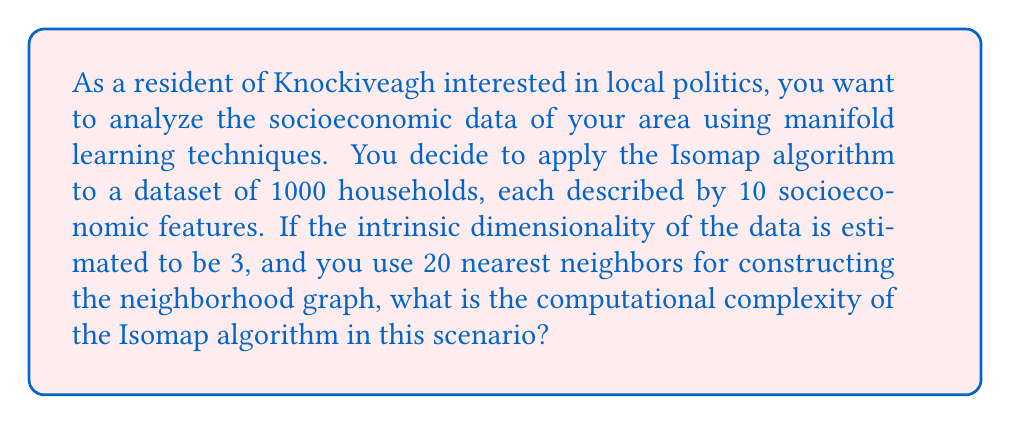Can you solve this math problem? To determine the computational complexity of the Isomap algorithm in this scenario, we need to consider the main steps of the algorithm and their respective complexities:

1. Construct the neighborhood graph:
   - For each point, find the k nearest neighbors (k = 20 in this case)
   - Complexity: $O(n^2d)$, where n is the number of data points (1000) and d is the original dimensionality (10)

2. Compute the shortest path distances:
   - Use Floyd-Warshall or Dijkstra's algorithm
   - Complexity: $O(n^3)$ for Floyd-Warshall or $O(n^2 \log n)$ for Dijkstra's algorithm

3. Perform Multidimensional Scaling (MDS):
   - Compute the eigendecomposition of the distance matrix
   - Complexity: $O(n^3)$

The overall complexity is dominated by the most computationally expensive step, which is either step 2 or 3, both having a complexity of $O(n^3)$.

Therefore, the computational complexity of the Isomap algorithm in this scenario is $O(n^3)$, where n = 1000.

It's worth noting that the intrinsic dimensionality (3) and the number of nearest neighbors (20) do not significantly affect the overall computational complexity in this case, as they are constant factors compared to the number of data points.
Answer: The computational complexity of the Isomap algorithm in this scenario is $O(n^3)$, where n = 1000. 